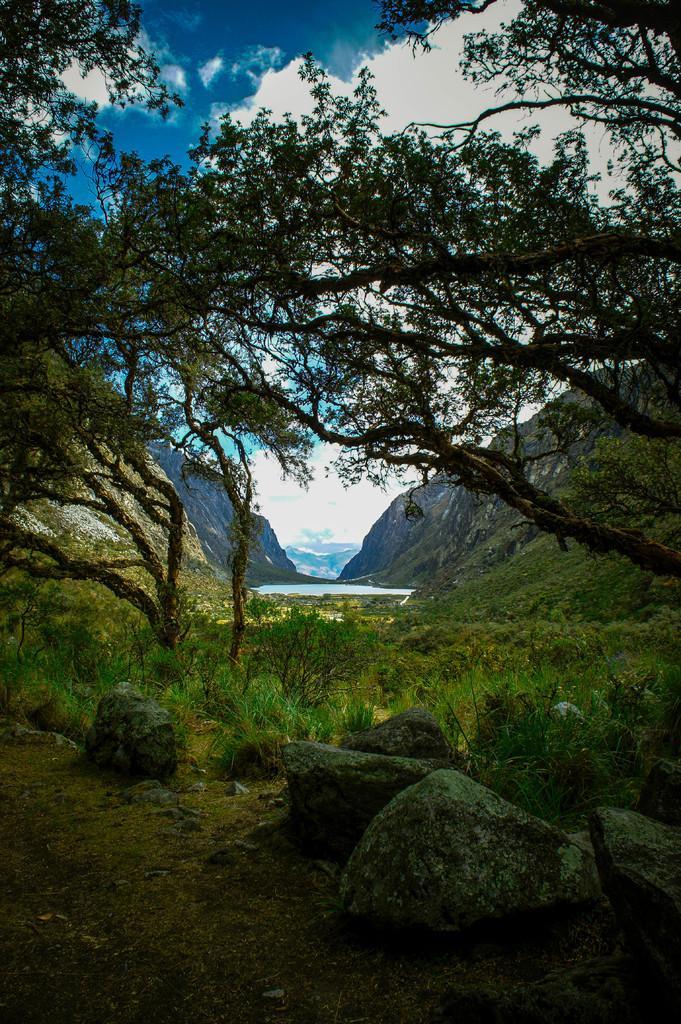Can you describe this image briefly? In this image, we can see some plants and trees. There are hills in the middle of the image. There are rocks at the bottom of the image. In the background of the image, there is a sky. 